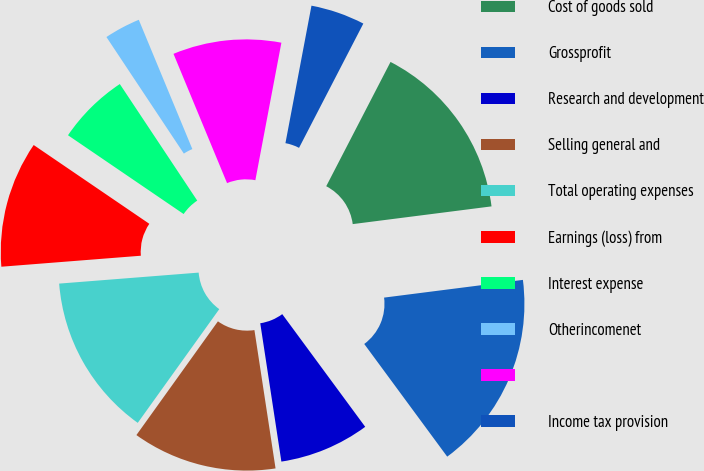Convert chart to OTSL. <chart><loc_0><loc_0><loc_500><loc_500><pie_chart><fcel>Cost of goods sold<fcel>Grossprofit<fcel>Research and development<fcel>Selling general and<fcel>Total operating expenses<fcel>Earnings (loss) from<fcel>Interest expense<fcel>Otherincomenet<fcel>Unnamed: 8<fcel>Income tax provision<nl><fcel>15.38%<fcel>16.92%<fcel>7.69%<fcel>12.31%<fcel>13.85%<fcel>10.77%<fcel>6.15%<fcel>3.08%<fcel>9.23%<fcel>4.62%<nl></chart> 